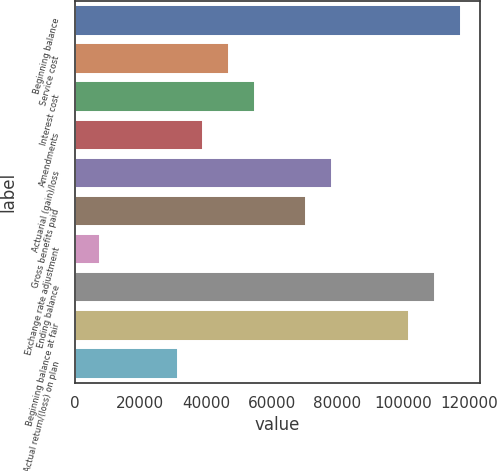<chart> <loc_0><loc_0><loc_500><loc_500><bar_chart><fcel>Beginning balance<fcel>Service cost<fcel>Interest cost<fcel>Amendments<fcel>Actuarial (gain)/loss<fcel>Gross benefits paid<fcel>Exchange rate adjustment<fcel>Ending balance<fcel>Beginning balance at fair<fcel>Actual return/(loss) on plan<nl><fcel>117584<fcel>47036.6<fcel>54875.2<fcel>39198<fcel>78391<fcel>70552.4<fcel>7843.6<fcel>109745<fcel>101907<fcel>31359.4<nl></chart> 